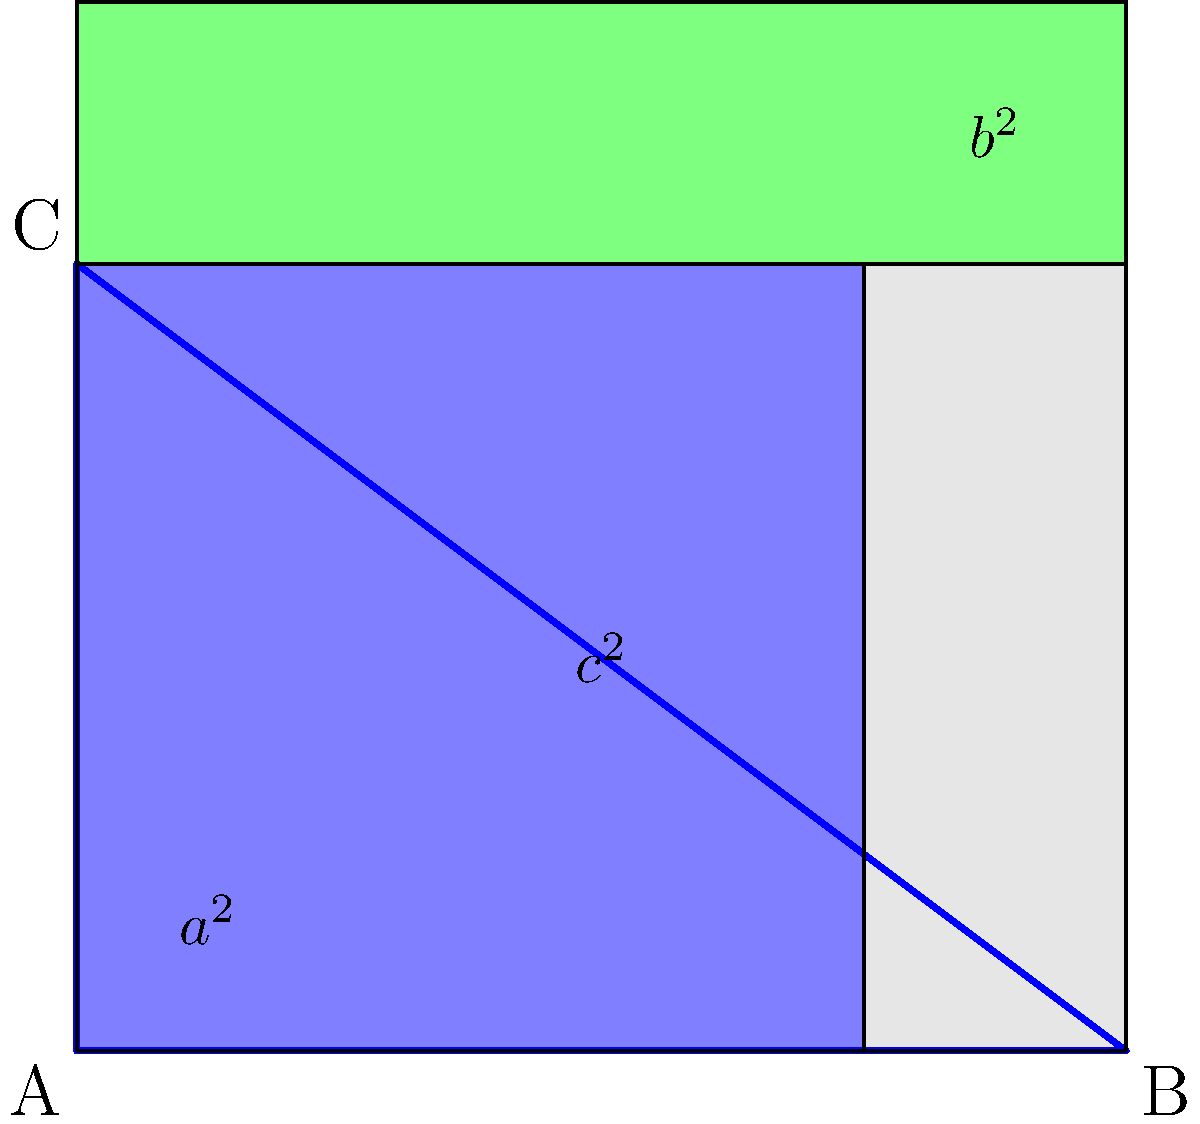In this viral geometric proof of the Pythagorean theorem, how does the area of the largest square relate to the areas of the two smaller squares, and what does this relationship represent in terms of the theorem? Let's break this down step-by-step:

1. The diagram shows a right-angled triangle ABC, where the right angle is at A.

2. Three squares are constructed:
   - A square on the hypotenuse (side BC), with area $c^2$
   - A square on side AB, with area $a^2$
   - A square on side AC, with area $b^2$

3. The Pythagorean theorem states that in a right-angled triangle, $a^2 + b^2 = c^2$, where c is the length of the hypotenuse.

4. In this diagram, we can see that:
   - The large square has area $c^2$
   - The two smaller squares have areas $a^2$ and $b^2$

5. The key observation is that the area of the large square ($c^2$) is equal to the sum of the areas of the two smaller squares ($a^2 + b^2$).

6. This visual representation directly proves the Pythagorean theorem, as it shows that $a^2 + b^2 = c^2$.

7. The beauty of this proof lies in its simplicity and visual appeal, making it easy to understand and share on social media platforms.
Answer: The area of the largest square ($c^2$) equals the sum of the areas of the two smaller squares ($a^2 + b^2$), visually proving the Pythagorean theorem. 